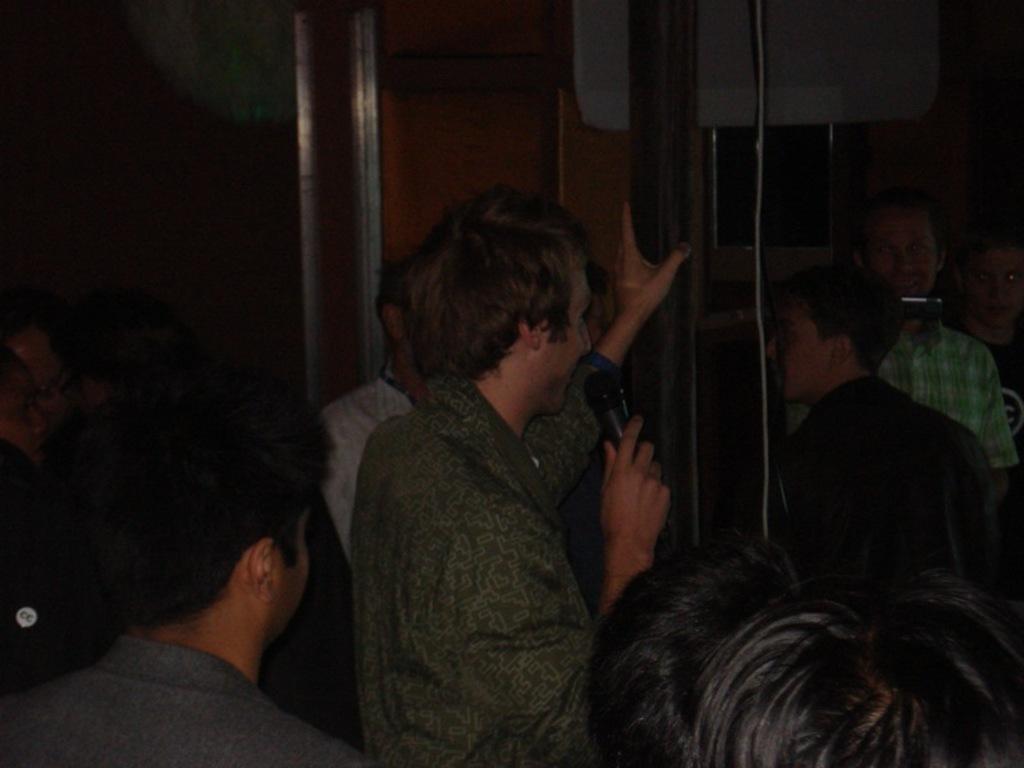Could you give a brief overview of what you see in this image? This picture is taken in the dark, where we can see a person wearing shirt is holding a mic in his hands and standing at the center of the image. Here we can see a few more people standing on the either side of the image. 